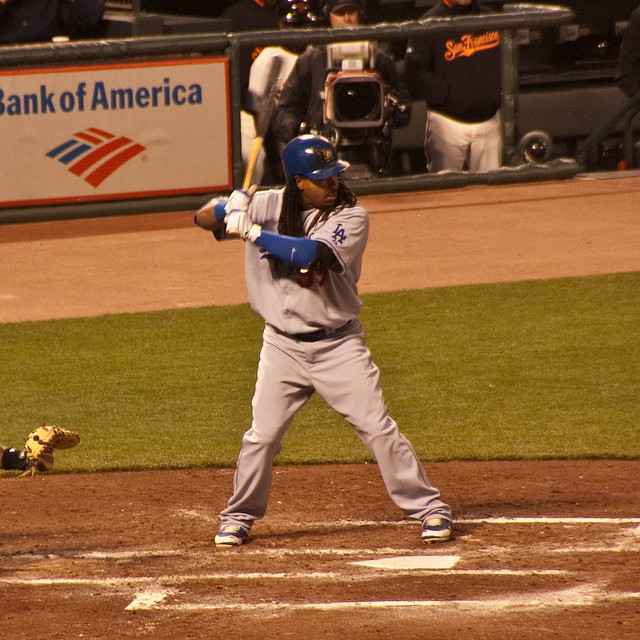Identify and read out the text in this image. America of ank LA San Francisco 